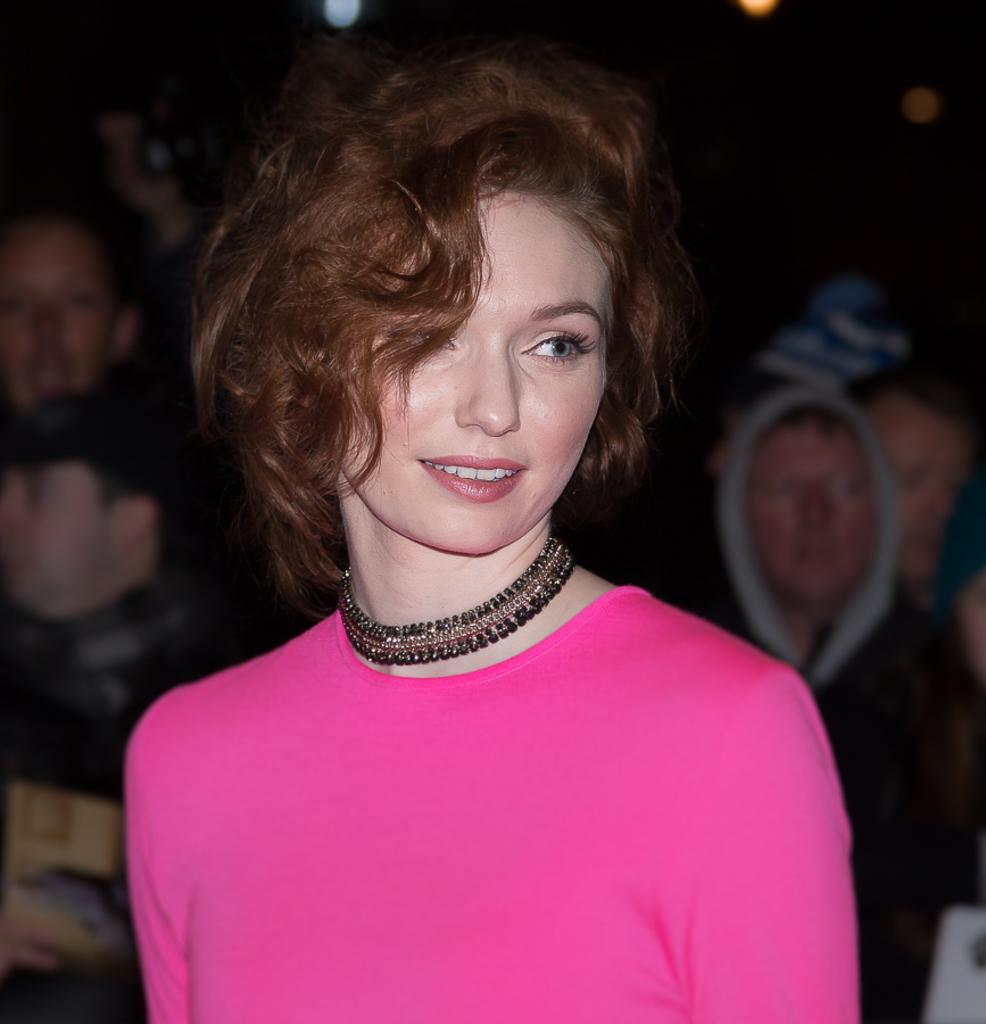Who is the main subject in the image? There is a woman in the image. What is the woman wearing? The woman is wearing a pink dress and a black necklace. Can you describe the other people visible in the image? There are other persons visible in the background of the image. What type of baseball bat is the woman holding in the image? There is no baseball bat present in the image. Can you describe the ray that is swimming near the woman in the image? There is no ray visible in the image; it only features a woman and other persons in the background. 